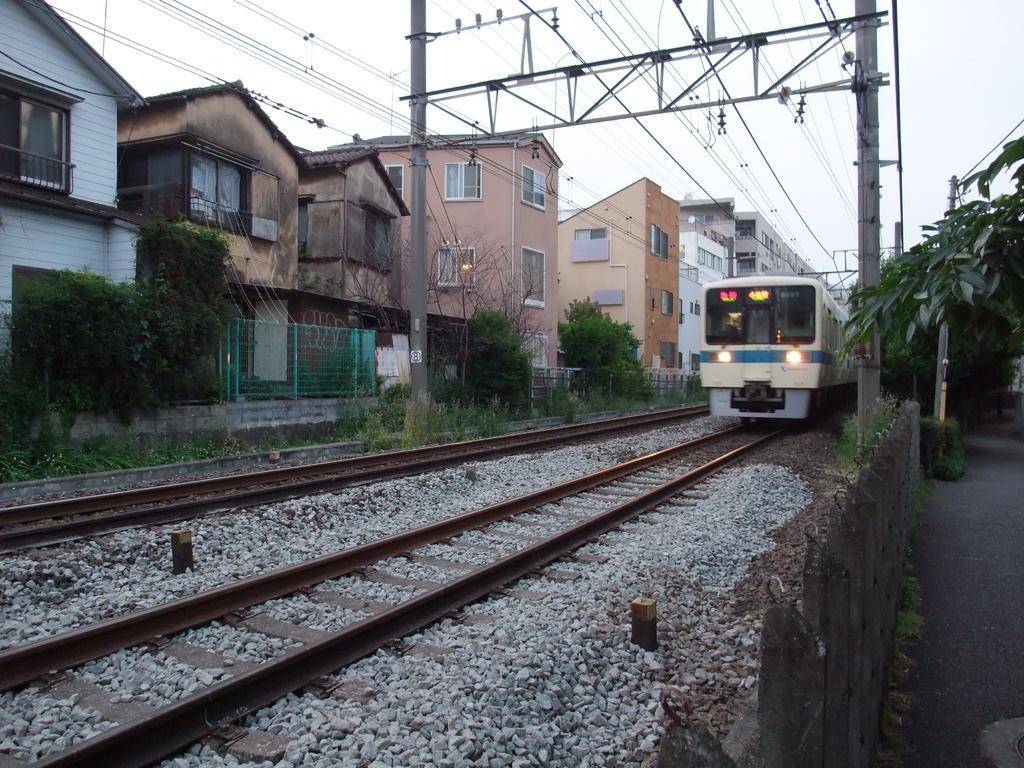Please provide a concise description of this image. In this image there is a train moving on the railway track. There are stones, railway tracks and grass on the ground. Beside the tracks there are electric poles. To the right there is a road. To the left there are buildings and plants. At the top there is the sky. 